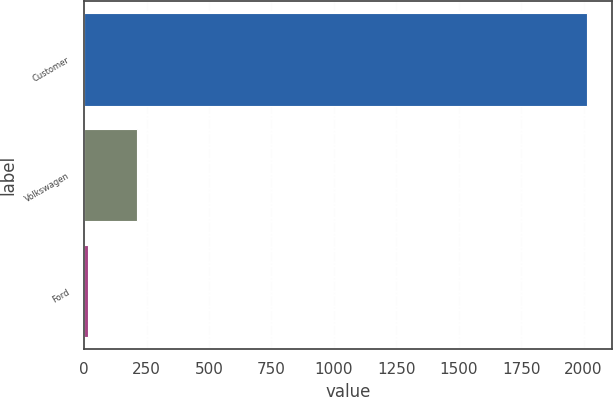Convert chart to OTSL. <chart><loc_0><loc_0><loc_500><loc_500><bar_chart><fcel>Customer<fcel>Volkswagen<fcel>Ford<nl><fcel>2014<fcel>213.1<fcel>13<nl></chart> 